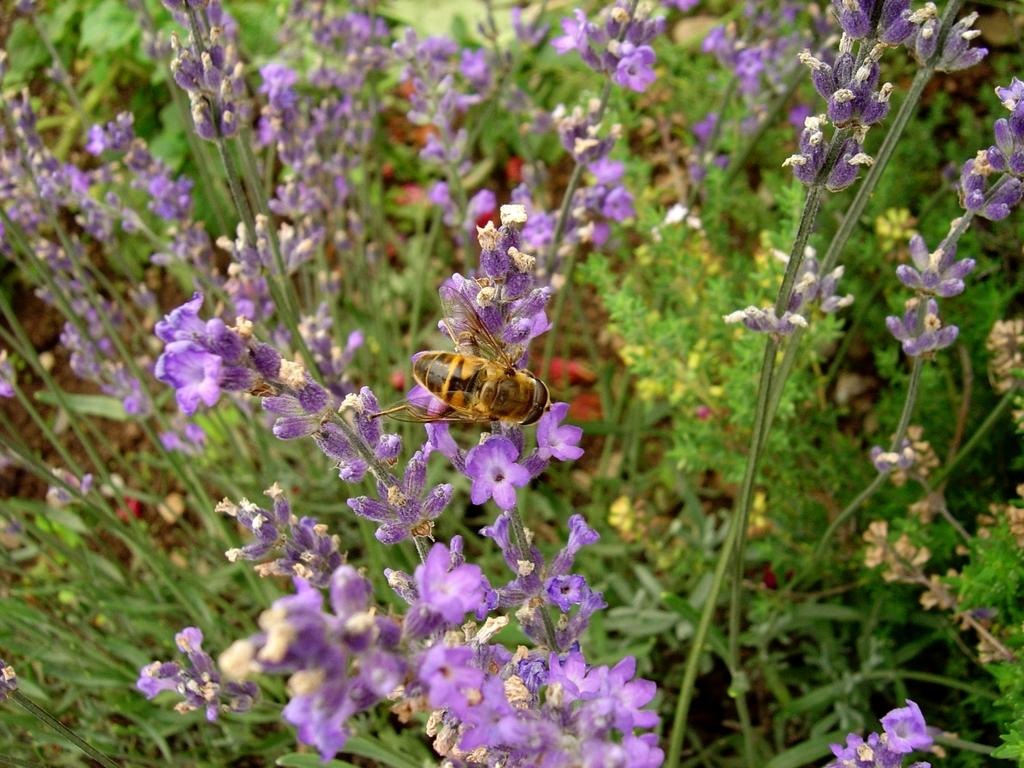What type of living organisms are present in the image? The image contains plants. What specific feature can be observed on the plants? The plants have flowers. What color are the flowers? The flowers are purple in color. Are there any other creatures visible in the image? Yes, there is a honey bee in the image. What type of liquid can be seen dripping from the train in the image? There is no train present in the image, so it is not possible to determine if any liquid is dripping from it. 